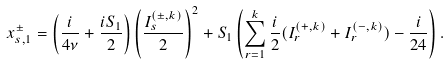Convert formula to latex. <formula><loc_0><loc_0><loc_500><loc_500>x ^ { \pm } _ { s , 1 } = \left ( \frac { i } { 4 \nu } + \frac { i S _ { 1 } } { 2 } \right ) \left ( \frac { I ^ { ( \pm , k ) } _ { s } } { 2 } \right ) ^ { 2 } + S _ { 1 } \left ( \sum _ { r = 1 } ^ { k } \frac { i } { 2 } ( I ^ { ( + , k ) } _ { r } + I ^ { ( - , k ) } _ { r } ) - \frac { i } { 2 4 } \right ) .</formula> 